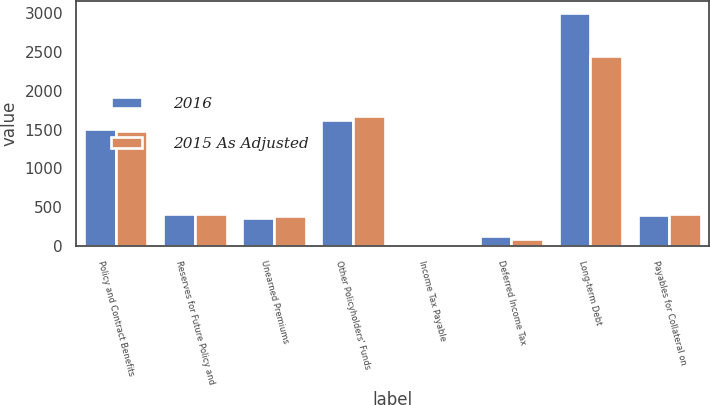Convert chart to OTSL. <chart><loc_0><loc_0><loc_500><loc_500><stacked_bar_chart><ecel><fcel>Policy and Contract Benefits<fcel>Reserves for Future Policy and<fcel>Unearned Premiums<fcel>Other Policyholders' Funds<fcel>Income Tax Payable<fcel>Deferred Income Tax<fcel>Long-term Debt<fcel>Payables for Collateral on<nl><fcel>2016<fcel>1507.9<fcel>410.7<fcel>363.7<fcel>1623.8<fcel>20.6<fcel>130.3<fcel>2999.4<fcel>406<nl><fcel>2015 As Adjusted<fcel>1484.6<fcel>410.7<fcel>384.2<fcel>1674.6<fcel>6<fcel>91.8<fcel>2449.4<fcel>415.4<nl></chart> 